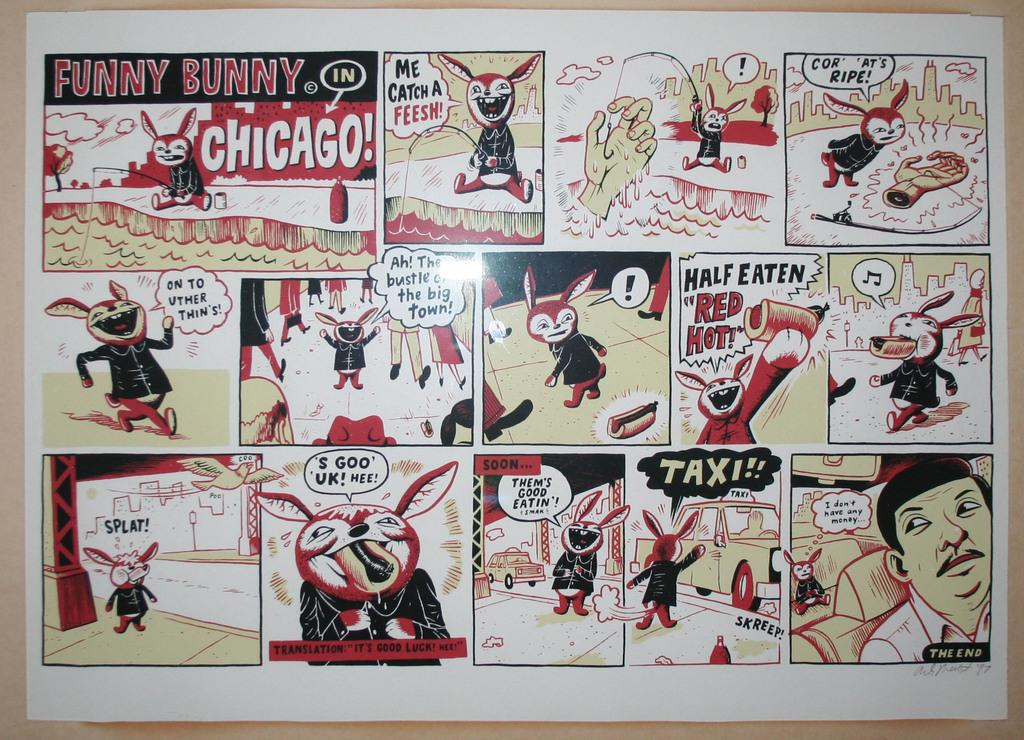Provide a one-sentence caption for the provided image. a comic strip of FUNNY BUNNY IN CHICAGO!. 